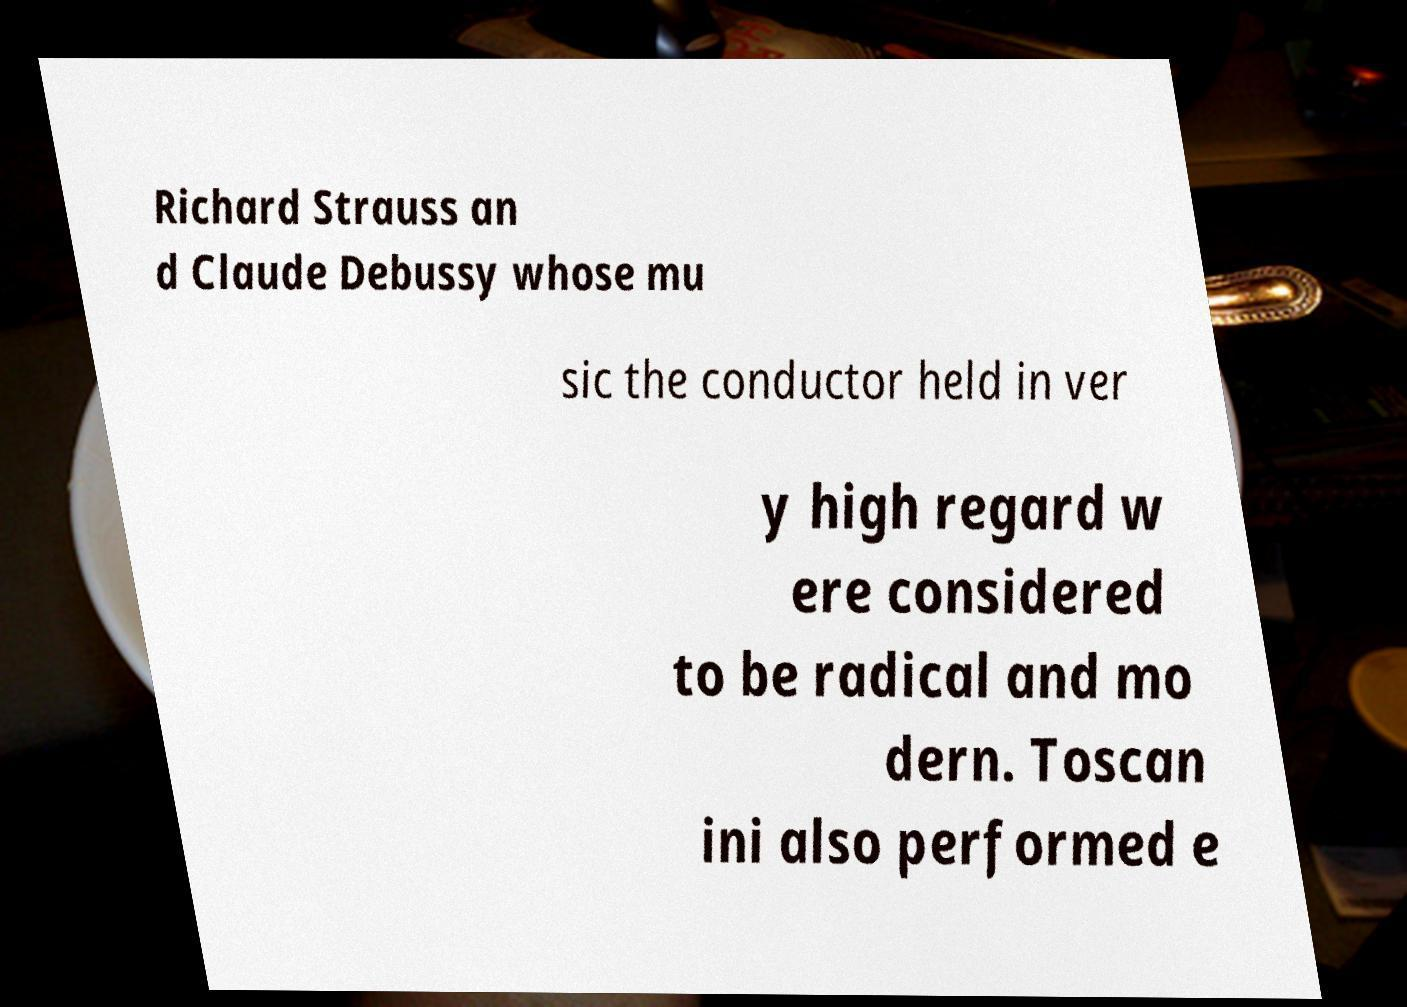Could you extract and type out the text from this image? Richard Strauss an d Claude Debussy whose mu sic the conductor held in ver y high regard w ere considered to be radical and mo dern. Toscan ini also performed e 